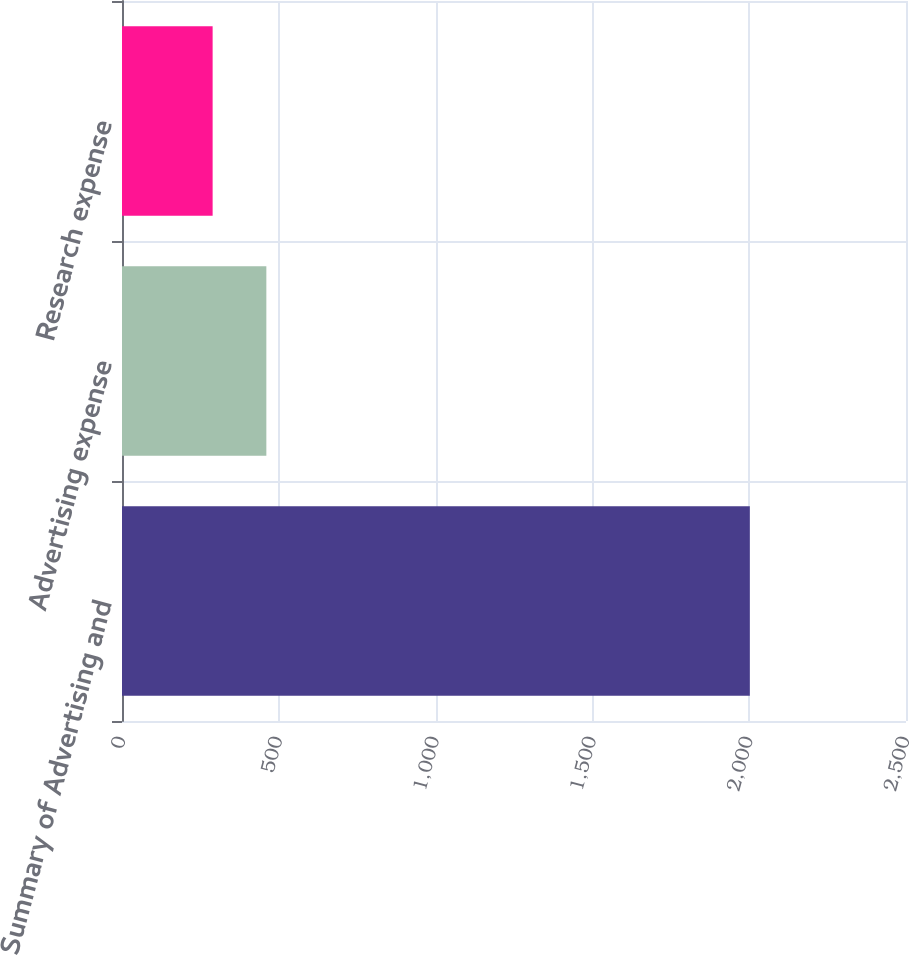<chart> <loc_0><loc_0><loc_500><loc_500><bar_chart><fcel>Summary of Advertising and<fcel>Advertising expense<fcel>Research expense<nl><fcel>2002<fcel>460.3<fcel>289<nl></chart> 